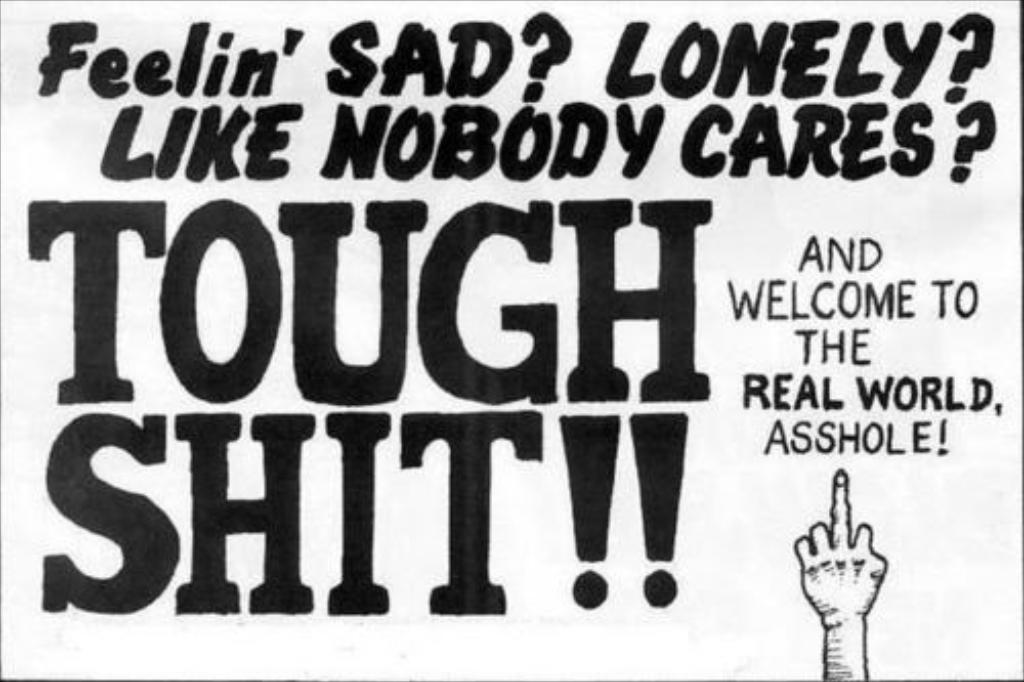<image>
Give a short and clear explanation of the subsequent image. A poster that says Feelin Sad Lonely like no one cares 